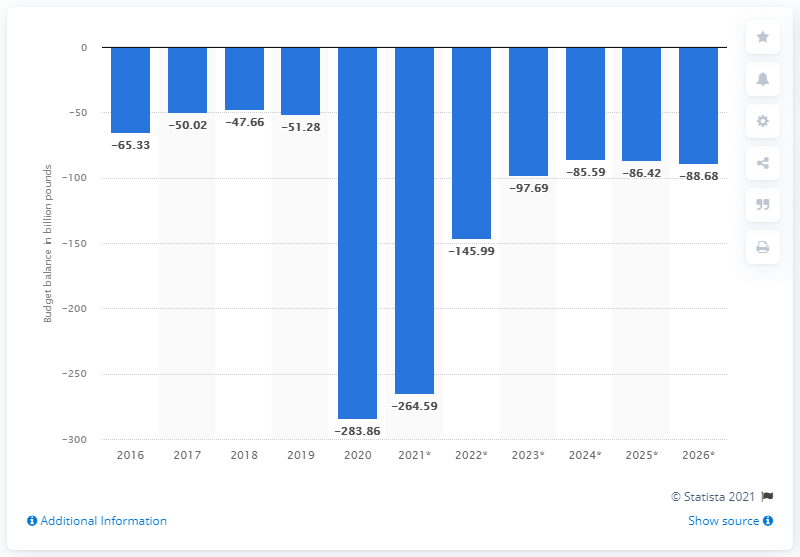Outline some significant characteristics in this image. In 2020, the budget balance in the United Kingdom was balanced. 